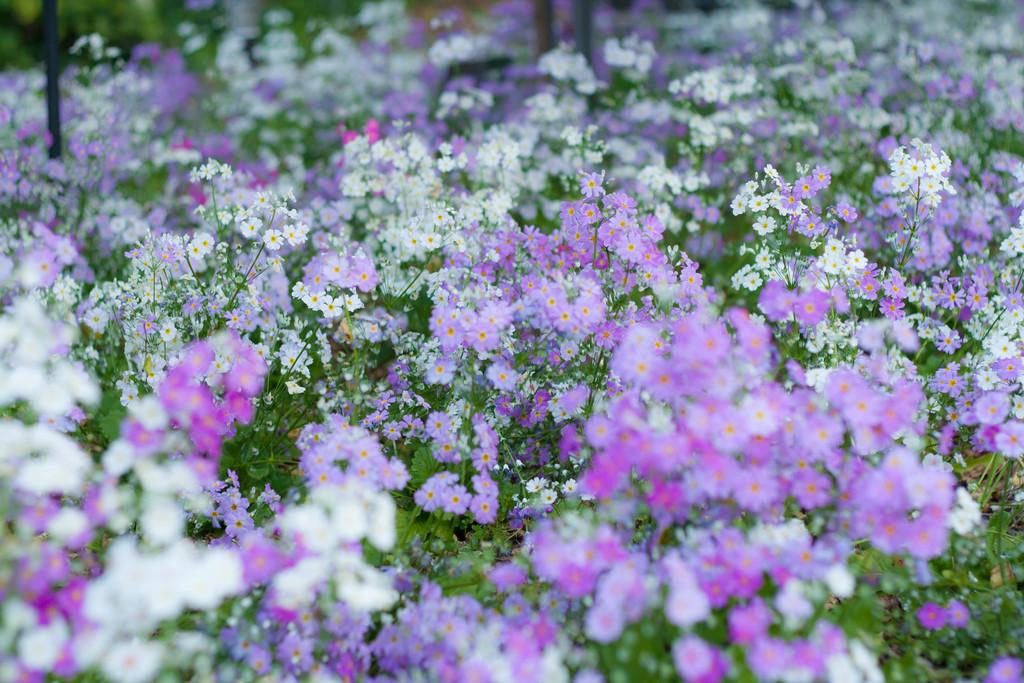What type of living organisms are present in the image? There is a group of plants in the image. What specific feature can be observed on the plants? The plants have flowers. What color are the flowers on the plants? The flowers are white and violet in color. Can you recite a verse about the water in the cellar in the image? There is no water or cellar present in the image, so there is no verse to recite about them. 